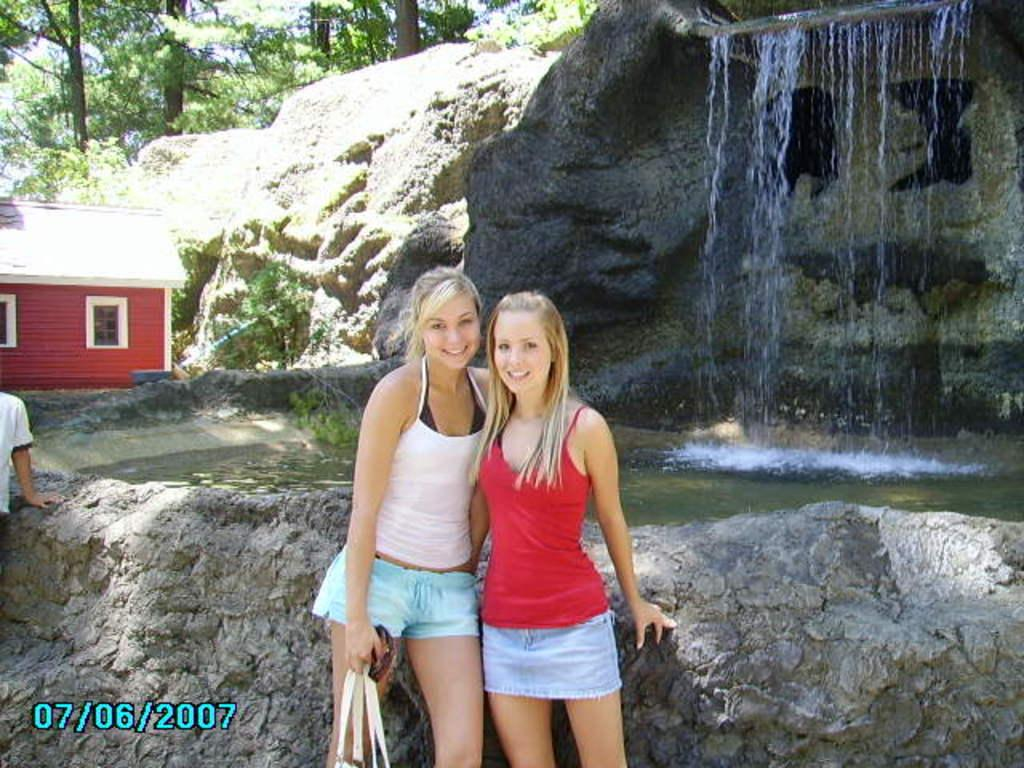<image>
Provide a brief description of the given image. The picture of the two girls infront of a waterfall was taken in 2007. 